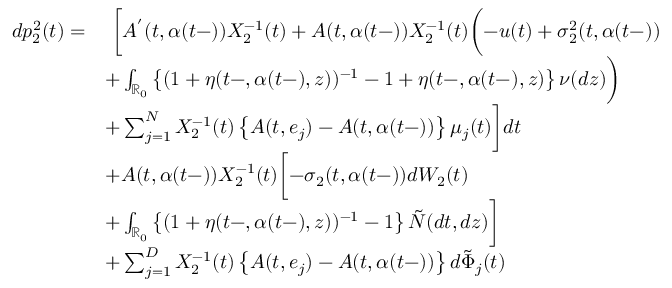<formula> <loc_0><loc_0><loc_500><loc_500>\begin{array} { r l } { d p _ { 2 } ^ { 2 } ( t ) = } & { \ \left [ A ^ { ^ { \prime } } ( t , \alpha ( t - ) ) X _ { 2 } ^ { - 1 } ( t ) + A ( t , \alpha ( t - ) ) X _ { 2 } ^ { - 1 } ( t ) \left ( - u ( t ) + \sigma _ { 2 } ^ { 2 } ( t , \alpha ( t - ) ) } \\ & { + \int _ { \mathbb { R } _ { 0 } } \left \{ ( 1 + \eta ( t - , \alpha ( t - ) , z ) ) ^ { - 1 } - 1 + \eta ( t - , \alpha ( t - ) , z ) \right \} \nu ( d z ) \right ) } \\ & { + \sum _ { j = 1 } ^ { N } X _ { 2 } ^ { - 1 } ( t ) \left \{ A ( t , e _ { j } ) - A ( t , \alpha ( t - ) ) \right \} \mu _ { j } ( t ) \right ] d t } \\ & { + A ( t , \alpha ( t - ) ) X _ { 2 } ^ { - 1 } ( t ) \left [ - \sigma _ { 2 } ( t , \alpha ( t - ) ) d W _ { 2 } ( t ) } \\ & { + \int _ { \mathbb { R } _ { 0 } } \left \{ ( 1 + \eta ( t - , \alpha ( t - ) , z ) ) ^ { - 1 } - 1 \right \} \tilde { N } ( d t , d z ) \right ] } \\ & { + \sum _ { j = 1 } ^ { D } X _ { 2 } ^ { - 1 } ( t ) \left \{ A ( t , e _ { j } ) - A ( t , \alpha ( t - ) ) \right \} d \tilde { \Phi } _ { j } ( t ) } \end{array}</formula> 